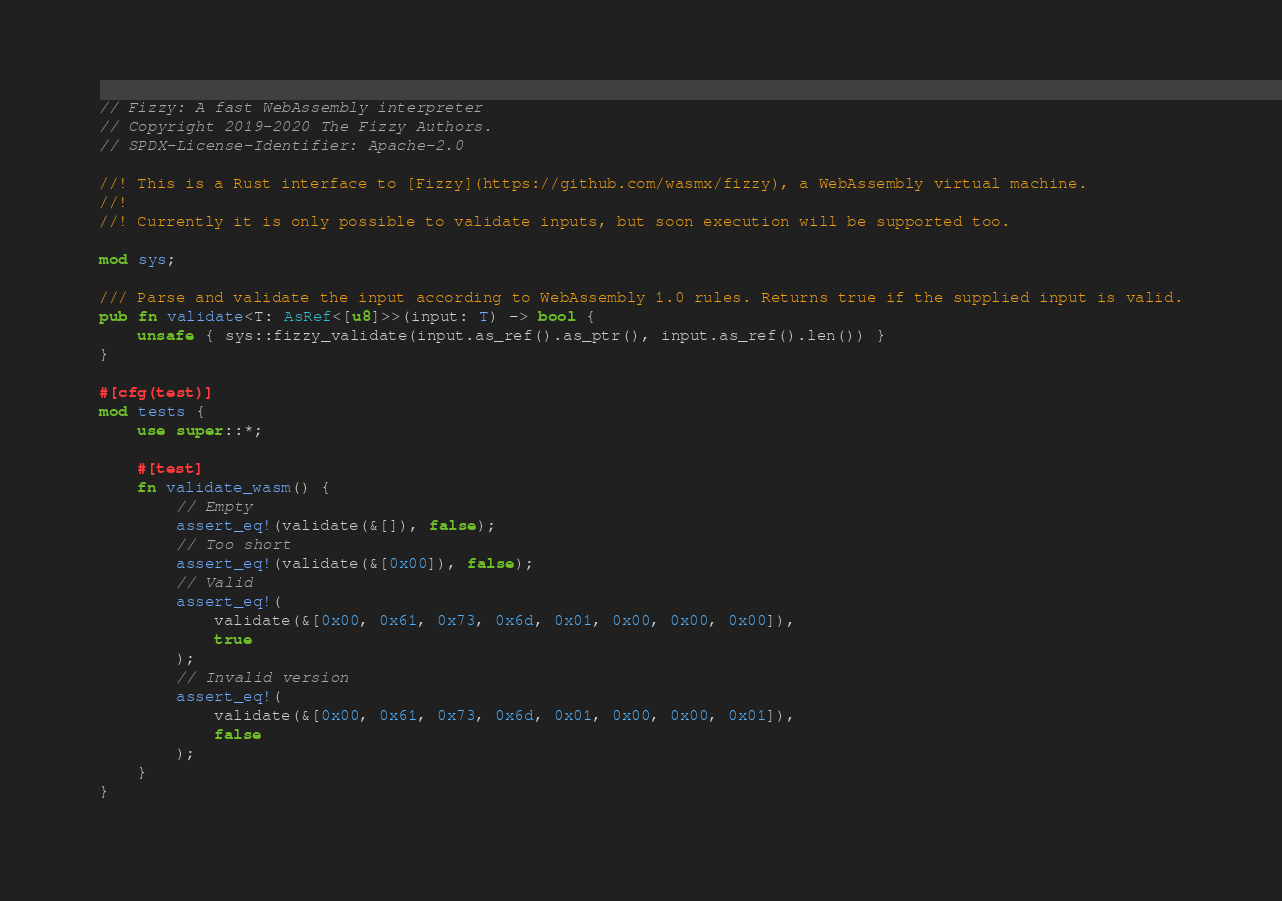<code> <loc_0><loc_0><loc_500><loc_500><_Rust_>// Fizzy: A fast WebAssembly interpreter
// Copyright 2019-2020 The Fizzy Authors.
// SPDX-License-Identifier: Apache-2.0

//! This is a Rust interface to [Fizzy](https://github.com/wasmx/fizzy), a WebAssembly virtual machine.
//!
//! Currently it is only possible to validate inputs, but soon execution will be supported too.

mod sys;

/// Parse and validate the input according to WebAssembly 1.0 rules. Returns true if the supplied input is valid.
pub fn validate<T: AsRef<[u8]>>(input: T) -> bool {
    unsafe { sys::fizzy_validate(input.as_ref().as_ptr(), input.as_ref().len()) }
}

#[cfg(test)]
mod tests {
    use super::*;

    #[test]
    fn validate_wasm() {
        // Empty
        assert_eq!(validate(&[]), false);
        // Too short
        assert_eq!(validate(&[0x00]), false);
        // Valid
        assert_eq!(
            validate(&[0x00, 0x61, 0x73, 0x6d, 0x01, 0x00, 0x00, 0x00]),
            true
        );
        // Invalid version
        assert_eq!(
            validate(&[0x00, 0x61, 0x73, 0x6d, 0x01, 0x00, 0x00, 0x01]),
            false
        );
    }
}
</code> 